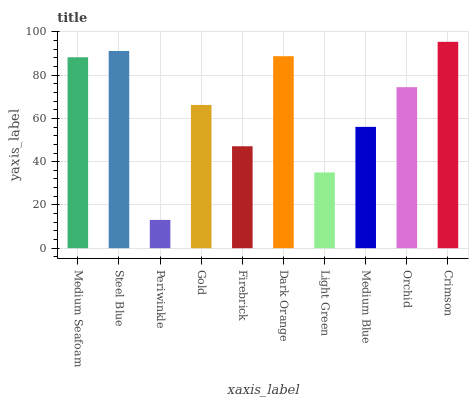Is Periwinkle the minimum?
Answer yes or no. Yes. Is Crimson the maximum?
Answer yes or no. Yes. Is Steel Blue the minimum?
Answer yes or no. No. Is Steel Blue the maximum?
Answer yes or no. No. Is Steel Blue greater than Medium Seafoam?
Answer yes or no. Yes. Is Medium Seafoam less than Steel Blue?
Answer yes or no. Yes. Is Medium Seafoam greater than Steel Blue?
Answer yes or no. No. Is Steel Blue less than Medium Seafoam?
Answer yes or no. No. Is Orchid the high median?
Answer yes or no. Yes. Is Gold the low median?
Answer yes or no. Yes. Is Medium Blue the high median?
Answer yes or no. No. Is Periwinkle the low median?
Answer yes or no. No. 